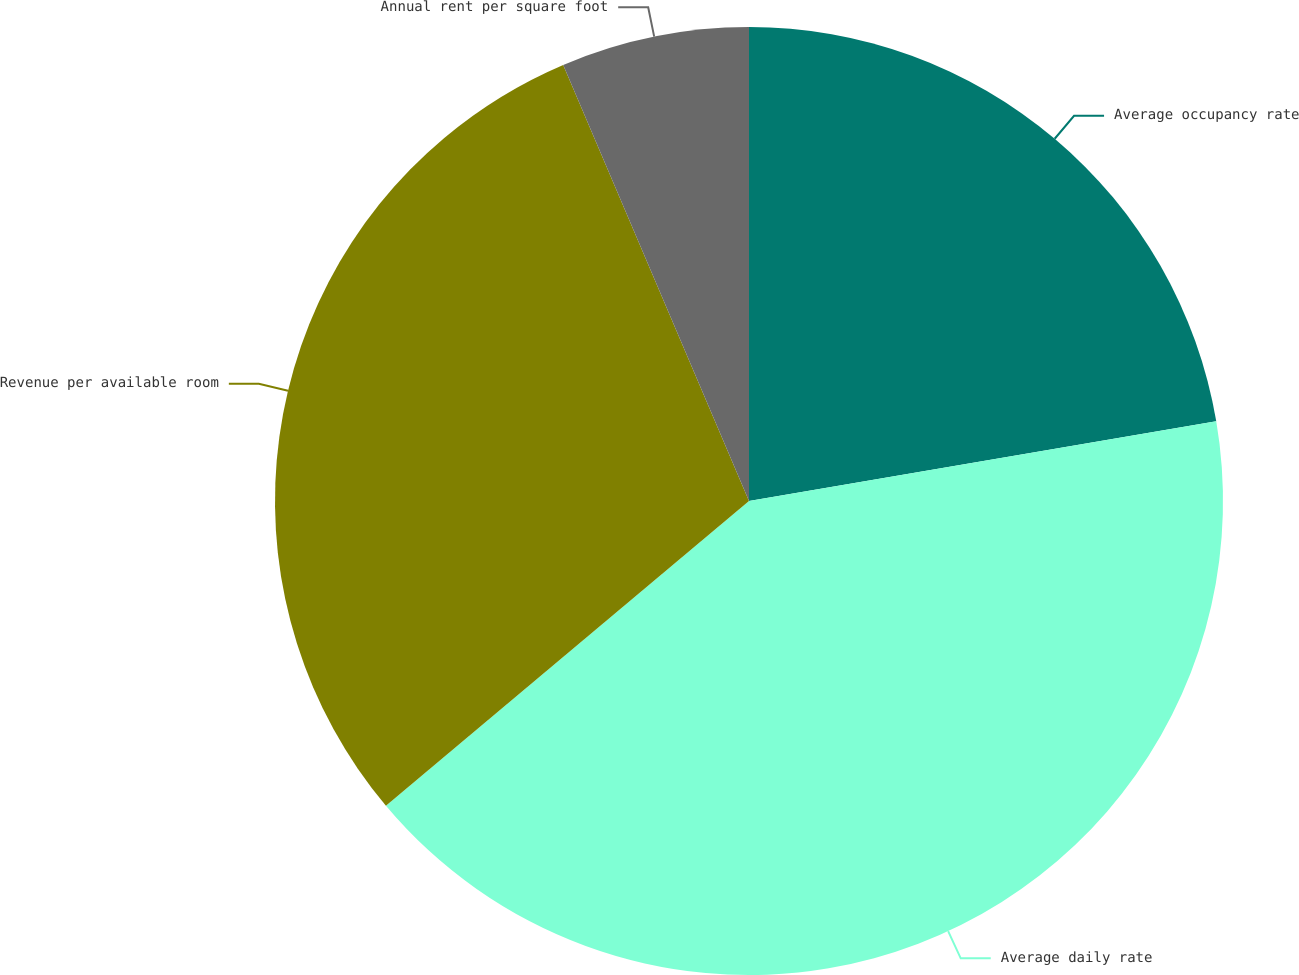Convert chart. <chart><loc_0><loc_0><loc_500><loc_500><pie_chart><fcel>Average occupancy rate<fcel>Average daily rate<fcel>Revenue per available room<fcel>Annual rent per square foot<nl><fcel>22.31%<fcel>41.57%<fcel>29.7%<fcel>6.41%<nl></chart> 